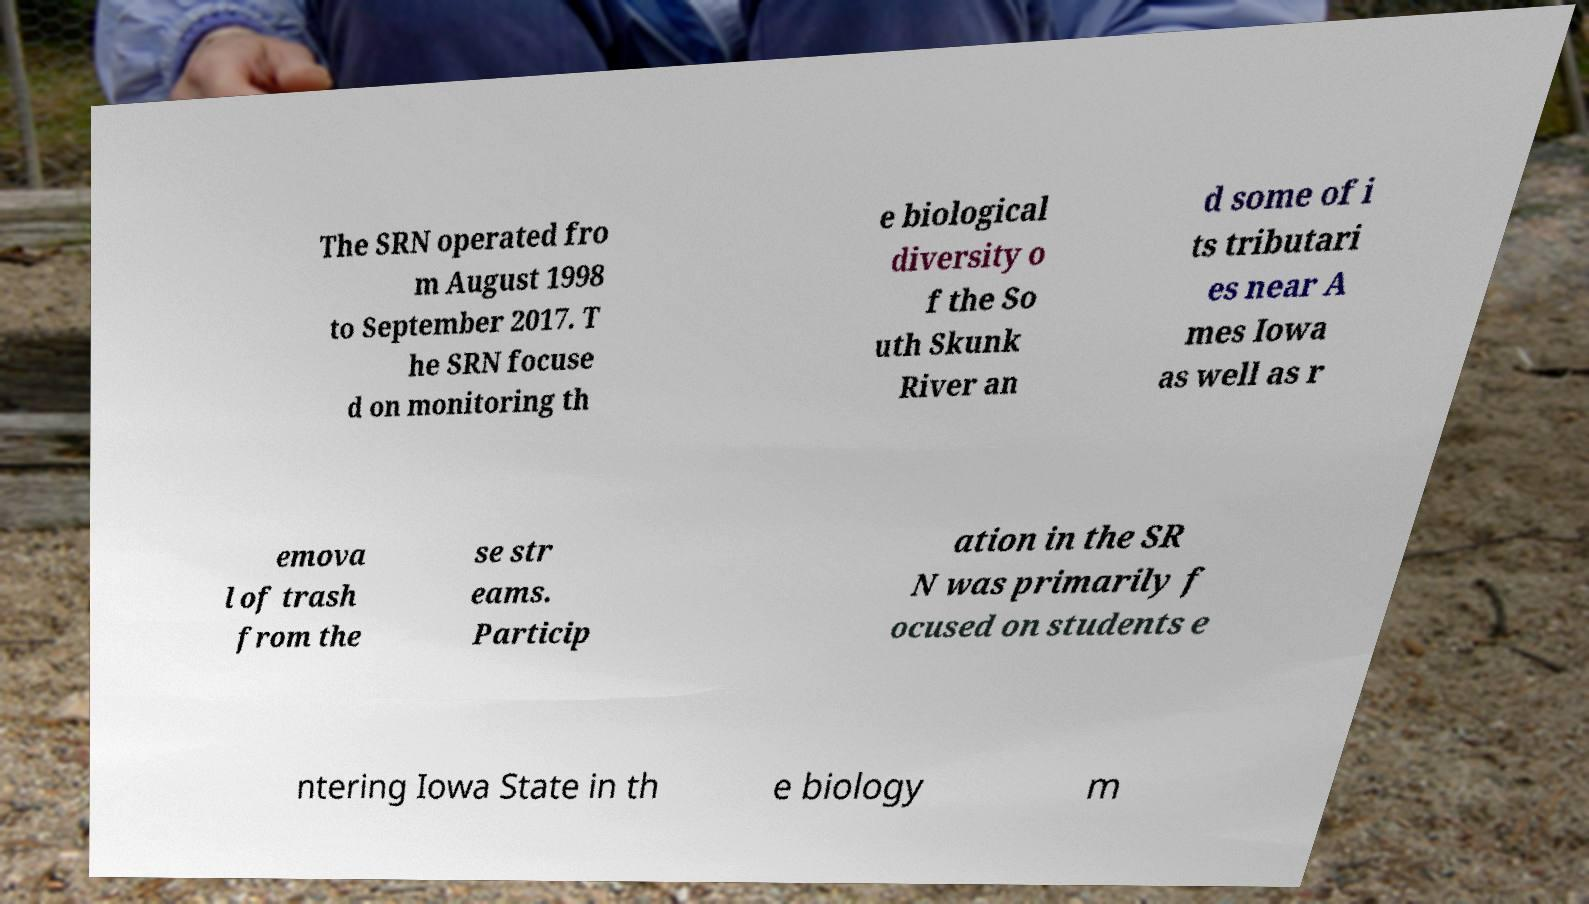There's text embedded in this image that I need extracted. Can you transcribe it verbatim? The SRN operated fro m August 1998 to September 2017. T he SRN focuse d on monitoring th e biological diversity o f the So uth Skunk River an d some of i ts tributari es near A mes Iowa as well as r emova l of trash from the se str eams. Particip ation in the SR N was primarily f ocused on students e ntering Iowa State in th e biology m 